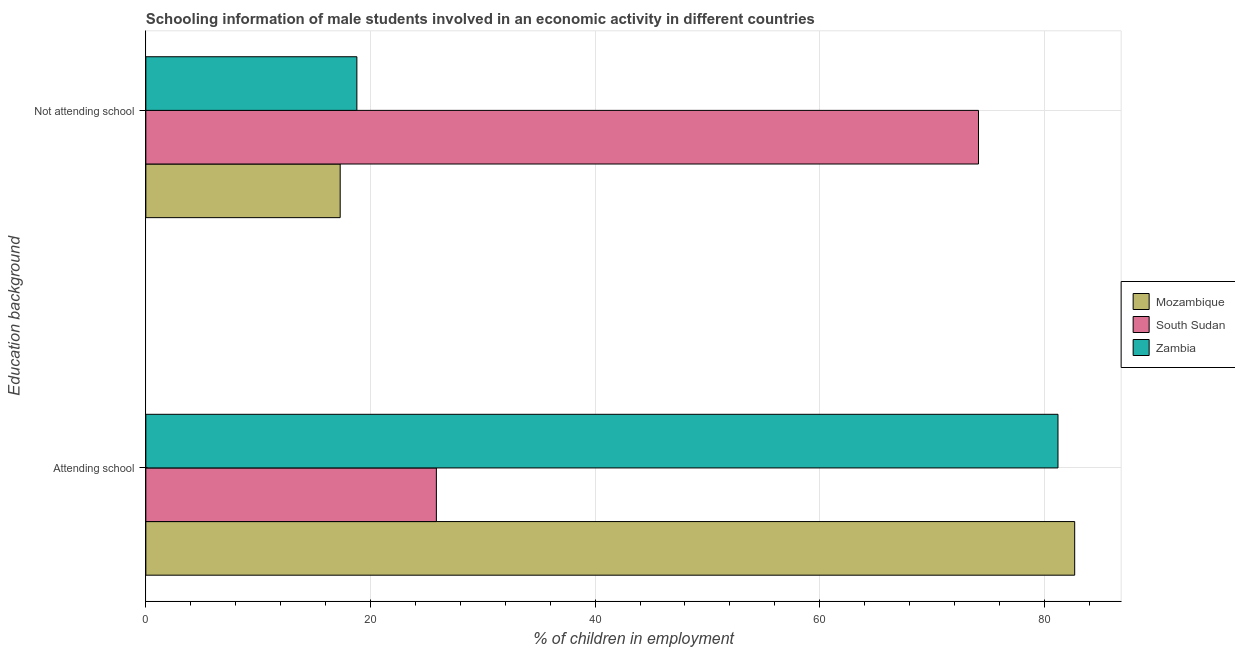How many different coloured bars are there?
Give a very brief answer. 3. How many groups of bars are there?
Your answer should be compact. 2. How many bars are there on the 2nd tick from the bottom?
Make the answer very short. 3. What is the label of the 1st group of bars from the top?
Ensure brevity in your answer.  Not attending school. What is the percentage of employed males who are attending school in South Sudan?
Your answer should be very brief. 25.87. Across all countries, what is the maximum percentage of employed males who are not attending school?
Provide a succinct answer. 74.13. Across all countries, what is the minimum percentage of employed males who are attending school?
Provide a succinct answer. 25.87. In which country was the percentage of employed males who are attending school maximum?
Provide a short and direct response. Mozambique. In which country was the percentage of employed males who are not attending school minimum?
Your answer should be very brief. Mozambique. What is the total percentage of employed males who are attending school in the graph?
Ensure brevity in your answer.  189.77. What is the difference between the percentage of employed males who are not attending school in Zambia and that in Mozambique?
Your answer should be compact. 1.49. What is the difference between the percentage of employed males who are attending school in Zambia and the percentage of employed males who are not attending school in South Sudan?
Your response must be concise. 7.08. What is the average percentage of employed males who are not attending school per country?
Offer a very short reply. 36.74. What is the difference between the percentage of employed males who are not attending school and percentage of employed males who are attending school in Mozambique?
Keep it short and to the point. -65.39. In how many countries, is the percentage of employed males who are not attending school greater than 4 %?
Keep it short and to the point. 3. What is the ratio of the percentage of employed males who are attending school in South Sudan to that in Zambia?
Your response must be concise. 0.32. Is the percentage of employed males who are not attending school in Mozambique less than that in South Sudan?
Offer a terse response. Yes. In how many countries, is the percentage of employed males who are attending school greater than the average percentage of employed males who are attending school taken over all countries?
Provide a succinct answer. 2. What does the 1st bar from the top in Not attending school represents?
Give a very brief answer. Zambia. What does the 2nd bar from the bottom in Attending school represents?
Your response must be concise. South Sudan. How many bars are there?
Your answer should be very brief. 6. What is the difference between two consecutive major ticks on the X-axis?
Your response must be concise. 20. Are the values on the major ticks of X-axis written in scientific E-notation?
Your answer should be very brief. No. Does the graph contain any zero values?
Provide a succinct answer. No. Where does the legend appear in the graph?
Provide a succinct answer. Center right. How are the legend labels stacked?
Your response must be concise. Vertical. What is the title of the graph?
Offer a very short reply. Schooling information of male students involved in an economic activity in different countries. Does "Morocco" appear as one of the legend labels in the graph?
Offer a terse response. No. What is the label or title of the X-axis?
Make the answer very short. % of children in employment. What is the label or title of the Y-axis?
Offer a very short reply. Education background. What is the % of children in employment in Mozambique in Attending school?
Your response must be concise. 82.7. What is the % of children in employment in South Sudan in Attending school?
Your answer should be compact. 25.87. What is the % of children in employment of Zambia in Attending school?
Your answer should be compact. 81.21. What is the % of children in employment of Mozambique in Not attending school?
Make the answer very short. 17.3. What is the % of children in employment of South Sudan in Not attending school?
Provide a short and direct response. 74.13. What is the % of children in employment in Zambia in Not attending school?
Give a very brief answer. 18.79. Across all Education background, what is the maximum % of children in employment of Mozambique?
Make the answer very short. 82.7. Across all Education background, what is the maximum % of children in employment of South Sudan?
Provide a short and direct response. 74.13. Across all Education background, what is the maximum % of children in employment in Zambia?
Offer a terse response. 81.21. Across all Education background, what is the minimum % of children in employment in Mozambique?
Offer a very short reply. 17.3. Across all Education background, what is the minimum % of children in employment in South Sudan?
Your response must be concise. 25.87. Across all Education background, what is the minimum % of children in employment of Zambia?
Offer a very short reply. 18.79. What is the difference between the % of children in employment of Mozambique in Attending school and that in Not attending school?
Your answer should be very brief. 65.39. What is the difference between the % of children in employment of South Sudan in Attending school and that in Not attending school?
Provide a succinct answer. -48.27. What is the difference between the % of children in employment of Zambia in Attending school and that in Not attending school?
Your answer should be compact. 62.42. What is the difference between the % of children in employment in Mozambique in Attending school and the % of children in employment in South Sudan in Not attending school?
Keep it short and to the point. 8.56. What is the difference between the % of children in employment in Mozambique in Attending school and the % of children in employment in Zambia in Not attending school?
Provide a short and direct response. 63.91. What is the difference between the % of children in employment in South Sudan in Attending school and the % of children in employment in Zambia in Not attending school?
Make the answer very short. 7.08. What is the average % of children in employment of Mozambique per Education background?
Offer a very short reply. 50. What is the average % of children in employment of South Sudan per Education background?
Make the answer very short. 50. What is the difference between the % of children in employment of Mozambique and % of children in employment of South Sudan in Attending school?
Offer a terse response. 56.83. What is the difference between the % of children in employment in Mozambique and % of children in employment in Zambia in Attending school?
Provide a succinct answer. 1.49. What is the difference between the % of children in employment of South Sudan and % of children in employment of Zambia in Attending school?
Give a very brief answer. -55.34. What is the difference between the % of children in employment of Mozambique and % of children in employment of South Sudan in Not attending school?
Ensure brevity in your answer.  -56.83. What is the difference between the % of children in employment in Mozambique and % of children in employment in Zambia in Not attending school?
Keep it short and to the point. -1.49. What is the difference between the % of children in employment in South Sudan and % of children in employment in Zambia in Not attending school?
Offer a terse response. 55.34. What is the ratio of the % of children in employment in Mozambique in Attending school to that in Not attending school?
Your response must be concise. 4.78. What is the ratio of the % of children in employment in South Sudan in Attending school to that in Not attending school?
Make the answer very short. 0.35. What is the ratio of the % of children in employment of Zambia in Attending school to that in Not attending school?
Offer a very short reply. 4.32. What is the difference between the highest and the second highest % of children in employment of Mozambique?
Your response must be concise. 65.39. What is the difference between the highest and the second highest % of children in employment of South Sudan?
Ensure brevity in your answer.  48.27. What is the difference between the highest and the second highest % of children in employment in Zambia?
Keep it short and to the point. 62.42. What is the difference between the highest and the lowest % of children in employment in Mozambique?
Ensure brevity in your answer.  65.39. What is the difference between the highest and the lowest % of children in employment in South Sudan?
Your answer should be compact. 48.27. What is the difference between the highest and the lowest % of children in employment of Zambia?
Your answer should be compact. 62.42. 